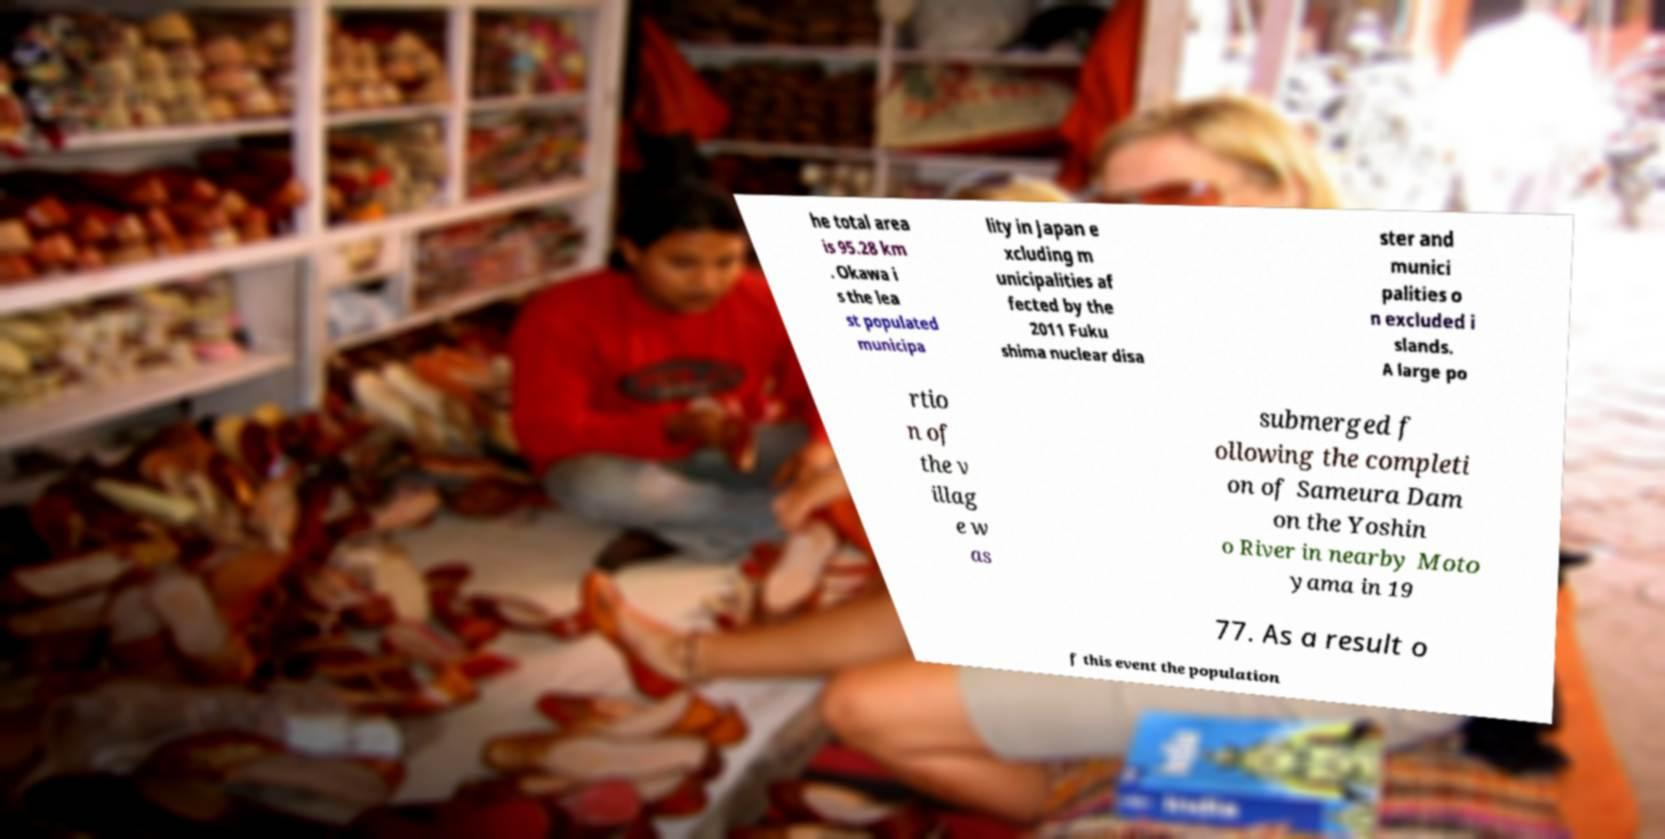What messages or text are displayed in this image? I need them in a readable, typed format. he total area is 95.28 km . Okawa i s the lea st populated municipa lity in Japan e xcluding m unicipalities af fected by the 2011 Fuku shima nuclear disa ster and munici palities o n excluded i slands. A large po rtio n of the v illag e w as submerged f ollowing the completi on of Sameura Dam on the Yoshin o River in nearby Moto yama in 19 77. As a result o f this event the population 